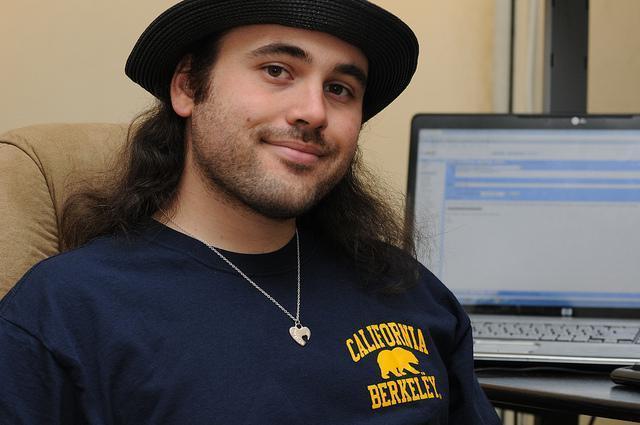How many people are visible?
Give a very brief answer. 1. How many donuts are in the plate?
Give a very brief answer. 0. 